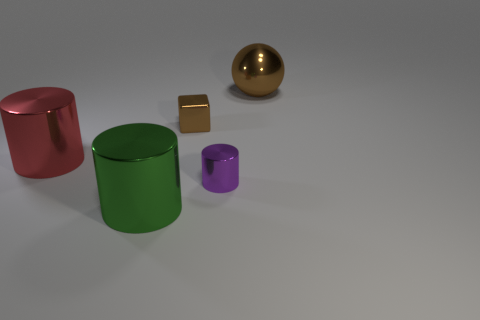Add 4 brown metal blocks. How many objects exist? 9 Subtract all cylinders. How many objects are left? 2 Add 5 large yellow matte blocks. How many large yellow matte blocks exist? 5 Subtract 1 brown balls. How many objects are left? 4 Subtract all small cyan objects. Subtract all large metal cylinders. How many objects are left? 3 Add 3 large green things. How many large green things are left? 4 